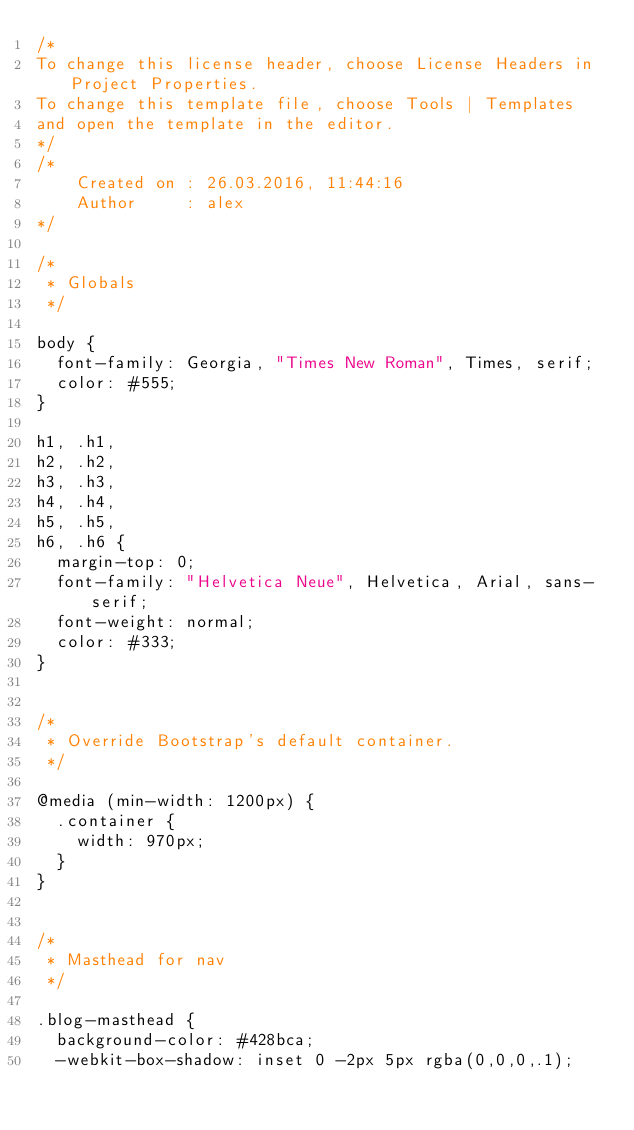Convert code to text. <code><loc_0><loc_0><loc_500><loc_500><_CSS_>/*
To change this license header, choose License Headers in Project Properties.
To change this template file, choose Tools | Templates
and open the template in the editor.
*/
/* 
    Created on : 26.03.2016, 11:44:16
    Author     : alex
*/

/*
 * Globals
 */

body {
  font-family: Georgia, "Times New Roman", Times, serif;
  color: #555;
}

h1, .h1,
h2, .h2,
h3, .h3,
h4, .h4,
h5, .h5,
h6, .h6 {
  margin-top: 0;
  font-family: "Helvetica Neue", Helvetica, Arial, sans-serif;
  font-weight: normal;
  color: #333;
}


/*
 * Override Bootstrap's default container.
 */

@media (min-width: 1200px) {
  .container {
    width: 970px;
  }
}


/*
 * Masthead for nav
 */

.blog-masthead {
  background-color: #428bca;
  -webkit-box-shadow: inset 0 -2px 5px rgba(0,0,0,.1);</code> 